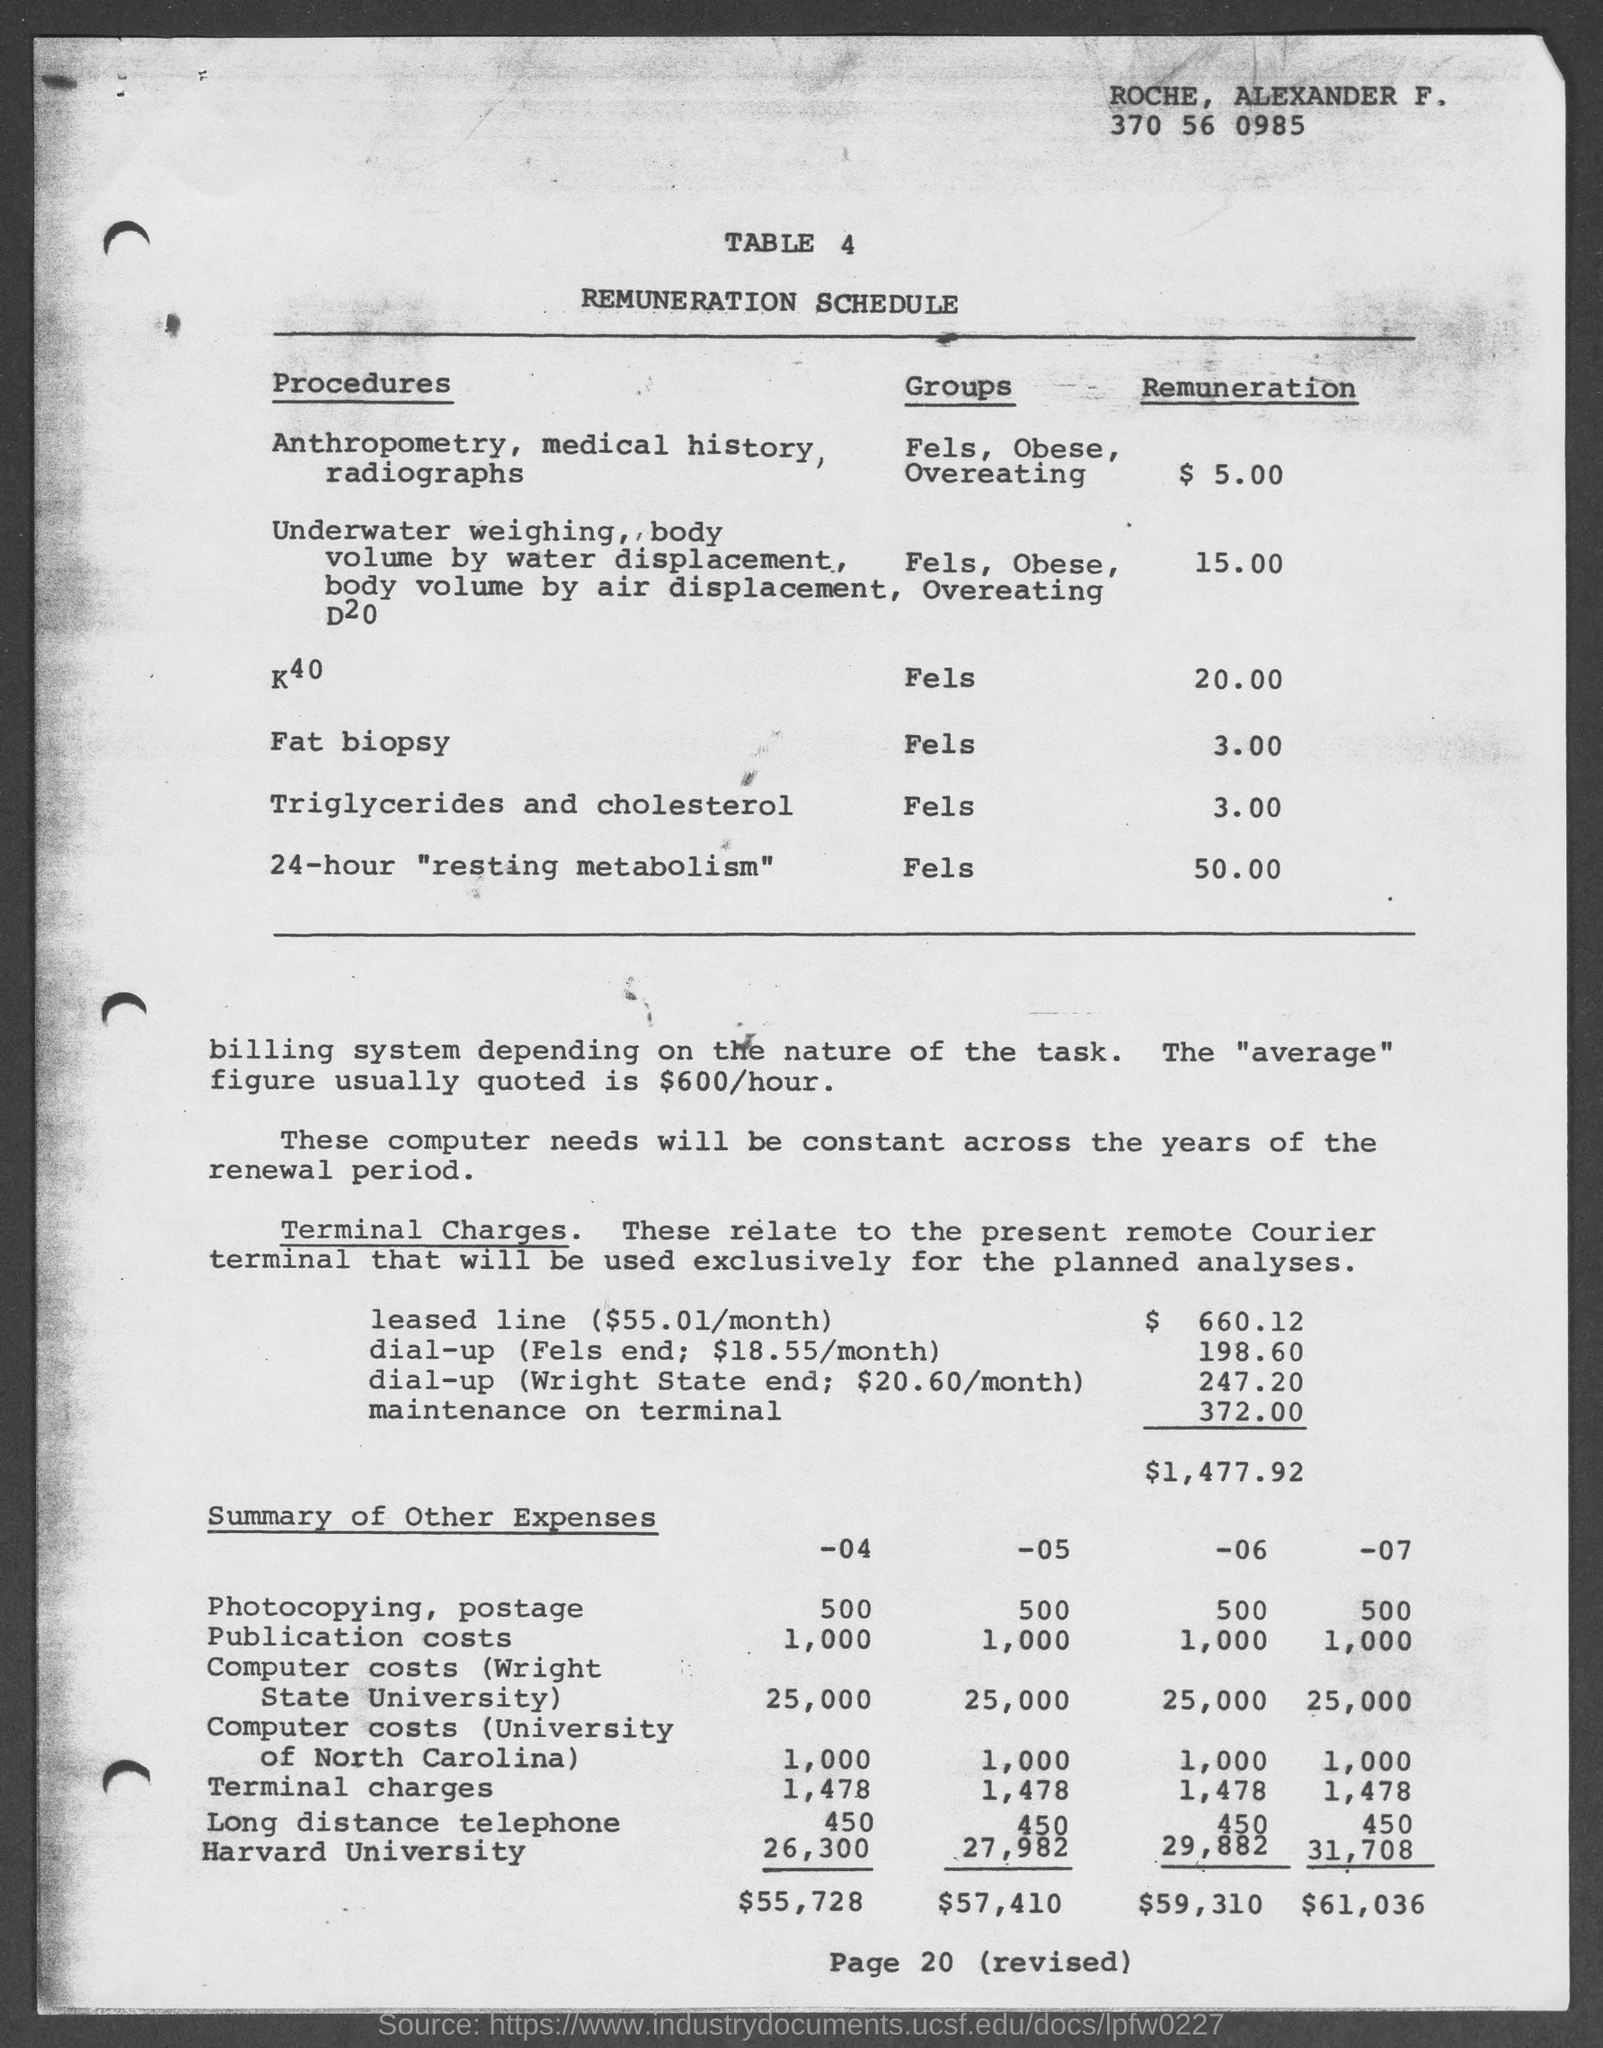Outline some significant characteristics in this image. The page number at the bottom of the page is 20. The title of Table 4 is 'Remuneration Schedule.' The table number is 4. 